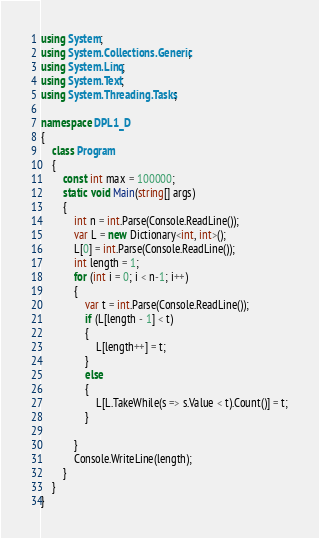Convert code to text. <code><loc_0><loc_0><loc_500><loc_500><_C#_>using System;
using System.Collections.Generic;
using System.Linq;
using System.Text;
using System.Threading.Tasks;

namespace DPL1_D
{
    class Program
    {
        const int max = 100000;
        static void Main(string[] args)
        {
            int n = int.Parse(Console.ReadLine());
            var L = new Dictionary<int, int>();
            L[0] = int.Parse(Console.ReadLine());
            int length = 1;
            for (int i = 0; i < n-1; i++)
            {
                var t = int.Parse(Console.ReadLine());
                if (L[length - 1] < t)
                {
                    L[length++] = t;
                }
                else
                {
                    L[L.TakeWhile(s => s.Value < t).Count()] = t;
                }

            }
            Console.WriteLine(length);
        }
    }
}</code> 